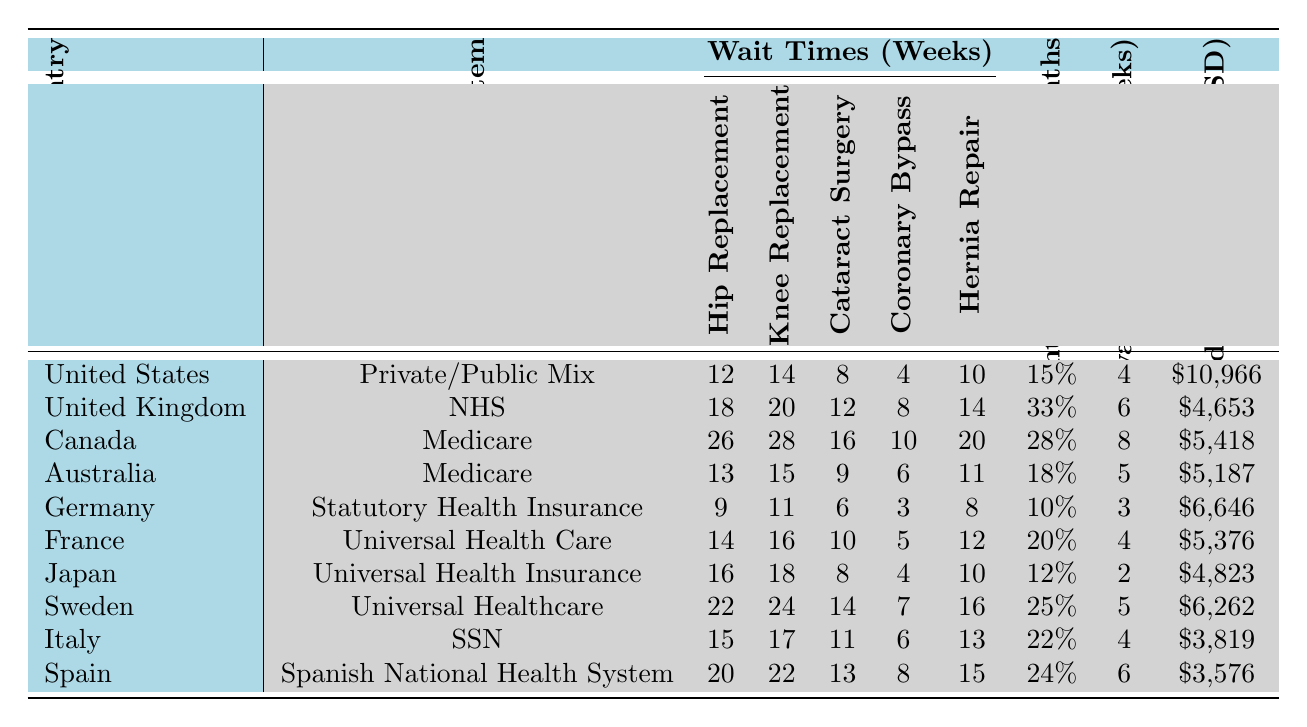What is the longest wait time for elective hip replacement among the listed countries? The longest wait time for elective hip replacement is found in Canada, where it is 26 weeks. This is identified by scanning the relevant column for hip replacement wait times and determining the maximum value.
Answer: 26 weeks Which country has the shortest wait time for cataract surgery? The shortest wait time for cataract surgery is in Germany, where the wait time is 6 weeks. We identify this by looking across the cataract surgery column and selecting the minimum value.
Answer: 6 weeks What is the average wait time for elective knee replacements across all countries? To find the average wait time for elective knee replacements, we sum the wait times: (14 + 20 + 28 + 15 + 11 + 16 + 18 + 24 + 17 + 22) =  175. There are 10 data points, so we divide 175 by 10 to get the average: 175 / 10 = 17.5 weeks.
Answer: 17.5 weeks Is the percentage of patients waiting over 6 months higher in the UK or in Canada? The percentage of patients waiting over 6 months is 33% in the UK and 28% in Canada. By comparing these two values directly from the table, it's clear that the UK has a higher percentage.
Answer: Yes, it is higher in the UK Which country shows the lowest public vs. private wait time difference for elective surgeries? The lowest public vs. private wait time difference is in Japan, with a difference of 2 weeks. This is found by checking the public vs. private difference column and identifying the minimum value.
Answer: 2 weeks If you combine the wait times for hip and knee replacements for each country, which country has the highest total wait time? First, we need to calculate the total wait time for hip and knee replacements for each country. The values are as follows: US (12+14=26), UK (18+20=38), Canada (26+28=54), Australia (13+15=28), Germany (9+11=20), France (14+16=30), Japan (16+18=34), Sweden (22+24=46), Italy (15+17=32), and Spain (20+22=42). The highest sum is 54 weeks for Canada.
Answer: Canada has the highest total wait time of 54 weeks How does the average annual healthcare spending per capita compare between the US and the UK? The average annual healthcare spending per capita in the US is $10,966, while in the UK it is $4,653. Comparing these two values shows that the US spends significantly more per capita.
Answer: The US has higher spending What percentage of patients in Sweden wait over 6 months for elective surgeries? The percentage of patients waiting over 6 months in Sweden is 25%. This value is directly referenced from the percentage patients waiting over 6 months column.
Answer: 25% Which country's hernia repair wait time exceeds the average hernia repair wait time across all countries? First, we must calculate the average hernia repair wait time: (10 + 14 + 20 + 11 + 8 + 12 + 10 + 16 + 13 + 15) =  11.9 weeks. The countries with wait times exceeding this are the UK (14), Canada (20), Sweden (16), and Spain (15). Thus, these countries exceed the average.
Answer: UK, Canada, Sweden, Spain exceed the average In which healthcare system do patients experience fewer weeks of wait time in public versus private care? The healthcare system with the least difference in wait time (2 weeks) is Japan, indicating that patients experience fewer weeks of wait time in public versus private care compared to other countries.
Answer: Japan has the least difference 